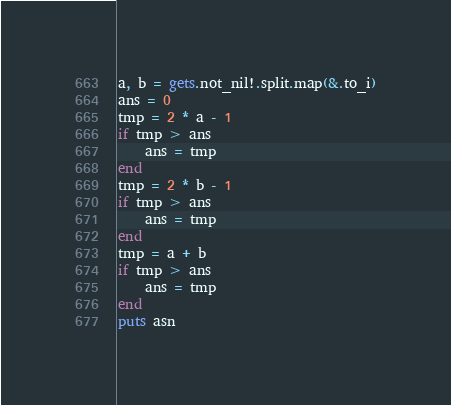Convert code to text. <code><loc_0><loc_0><loc_500><loc_500><_Crystal_>a, b = gets.not_nil!.split.map(&.to_i)
ans = 0
tmp = 2 * a - 1
if tmp > ans
	ans = tmp
end
tmp = 2 * b - 1
if tmp > ans
	ans = tmp
end
tmp = a + b
if tmp > ans
	ans = tmp
end
puts asn
</code> 